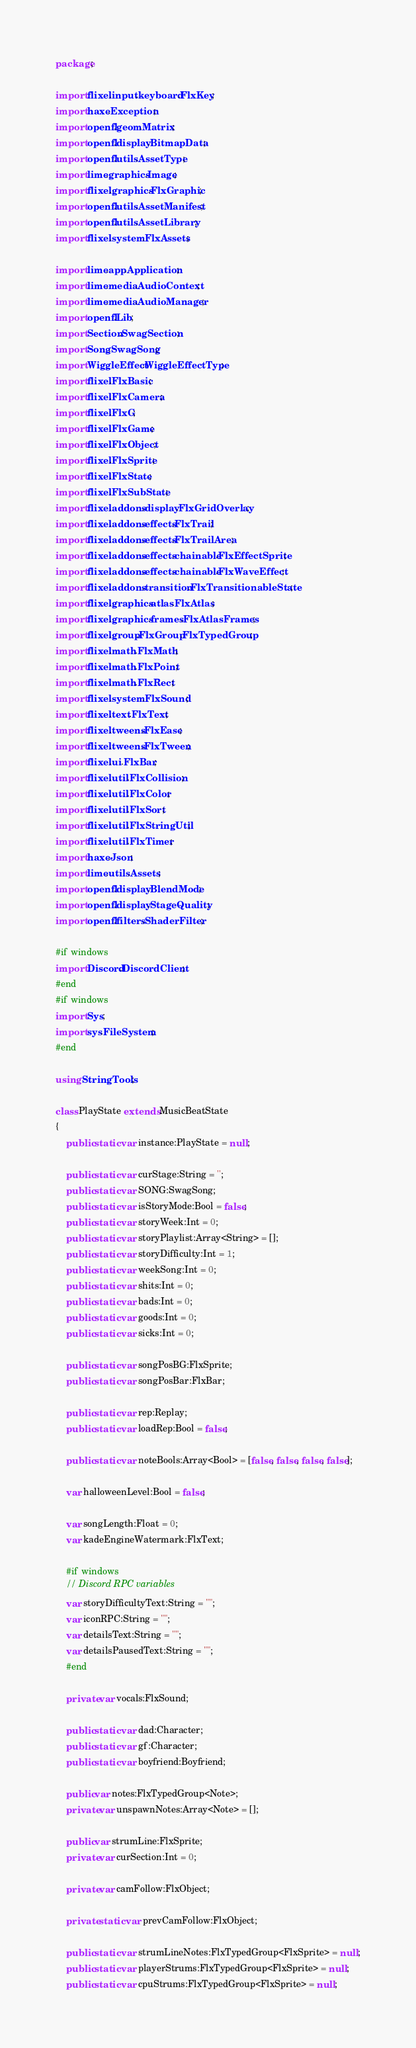<code> <loc_0><loc_0><loc_500><loc_500><_Haxe_>package;

import flixel.input.keyboard.FlxKey;
import haxe.Exception;
import openfl.geom.Matrix;
import openfl.display.BitmapData;
import openfl.utils.AssetType;
import lime.graphics.Image;
import flixel.graphics.FlxGraphic;
import openfl.utils.AssetManifest;
import openfl.utils.AssetLibrary;
import flixel.system.FlxAssets;

import lime.app.Application;
import lime.media.AudioContext;
import lime.media.AudioManager;
import openfl.Lib;
import Section.SwagSection;
import Song.SwagSong;
import WiggleEffect.WiggleEffectType;
import flixel.FlxBasic;
import flixel.FlxCamera;
import flixel.FlxG;
import flixel.FlxGame;
import flixel.FlxObject;
import flixel.FlxSprite;
import flixel.FlxState;
import flixel.FlxSubState;
import flixel.addons.display.FlxGridOverlay;
import flixel.addons.effects.FlxTrail;
import flixel.addons.effects.FlxTrailArea;
import flixel.addons.effects.chainable.FlxEffectSprite;
import flixel.addons.effects.chainable.FlxWaveEffect;
import flixel.addons.transition.FlxTransitionableState;
import flixel.graphics.atlas.FlxAtlas;
import flixel.graphics.frames.FlxAtlasFrames;
import flixel.group.FlxGroup.FlxTypedGroup;
import flixel.math.FlxMath;
import flixel.math.FlxPoint;
import flixel.math.FlxRect;
import flixel.system.FlxSound;
import flixel.text.FlxText;
import flixel.tweens.FlxEase;
import flixel.tweens.FlxTween;
import flixel.ui.FlxBar;
import flixel.util.FlxCollision;
import flixel.util.FlxColor;
import flixel.util.FlxSort;
import flixel.util.FlxStringUtil;
import flixel.util.FlxTimer;
import haxe.Json;
import lime.utils.Assets;
import openfl.display.BlendMode;
import openfl.display.StageQuality;
import openfl.filters.ShaderFilter;

#if windows
import Discord.DiscordClient;
#end
#if windows
import Sys;
import sys.FileSystem;
#end

using StringTools;

class PlayState extends MusicBeatState
{
	public static var instance:PlayState = null;

	public static var curStage:String = '';
	public static var SONG:SwagSong;
	public static var isStoryMode:Bool = false;
	public static var storyWeek:Int = 0;
	public static var storyPlaylist:Array<String> = [];
	public static var storyDifficulty:Int = 1;
	public static var weekSong:Int = 0;
	public static var shits:Int = 0;
	public static var bads:Int = 0;
	public static var goods:Int = 0;
	public static var sicks:Int = 0;

	public static var songPosBG:FlxSprite;
	public static var songPosBar:FlxBar;

	public static var rep:Replay;
	public static var loadRep:Bool = false;

	public static var noteBools:Array<Bool> = [false, false, false, false];

	var halloweenLevel:Bool = false;

	var songLength:Float = 0;
	var kadeEngineWatermark:FlxText;
	
	#if windows
	// Discord RPC variables
	var storyDifficultyText:String = "";
	var iconRPC:String = "";
	var detailsText:String = "";
	var detailsPausedText:String = "";
	#end

	private var vocals:FlxSound;

	public static var dad:Character;
	public static var gf:Character;
	public static var boyfriend:Boyfriend;

	public var notes:FlxTypedGroup<Note>;
	private var unspawnNotes:Array<Note> = [];

	public var strumLine:FlxSprite;
	private var curSection:Int = 0;

	private var camFollow:FlxObject;

	private static var prevCamFollow:FlxObject;

	public static var strumLineNotes:FlxTypedGroup<FlxSprite> = null;
	public static var playerStrums:FlxTypedGroup<FlxSprite> = null;
	public static var cpuStrums:FlxTypedGroup<FlxSprite> = null;
</code> 